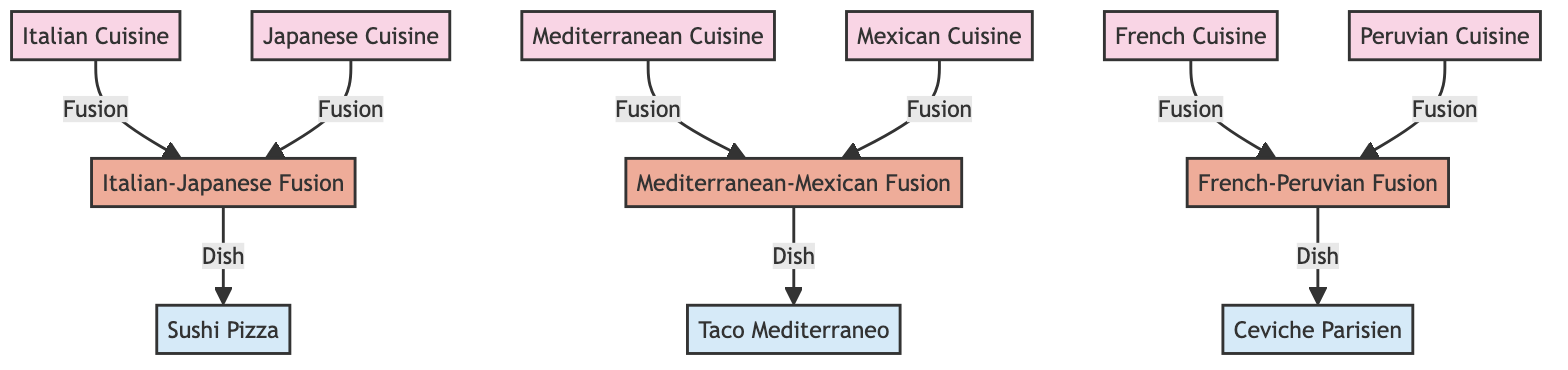What are the different cuisines represented in the diagram? The diagram contains nodes for Italian Cuisine, Japanese Cuisine, Mexican Cuisine, Mediterranean Cuisine, Peruvian Cuisine, and French Cuisine.
Answer: Italian Cuisine, Japanese Cuisine, Mexican Cuisine, Mediterranean Cuisine, Peruvian Cuisine, French Cuisine How many fusion cuisine types are listed? The diagram shows three fusion cuisine types: Italian-Japanese Fusion, Mediterranean-Mexican Fusion, and French-Peruvian Fusion.
Answer: Three What dish is associated with Italian-Japanese Fusion? According to the diagram, the dish associated with Italian-Japanese Fusion is Sushi Pizza.
Answer: Sushi Pizza Which cuisines influence the Mediterranean-Mexican Fusion? The Mediterranean-Mexican Fusion is influenced by Mediterranean Cuisine and Mexican Cuisine, as indicated by the edges connecting them.
Answer: Mediterranean Cuisine, Mexican Cuisine Which dish is associated with the French-Peruvian Fusion? The diagram indicates that the dish associated with the French-Peruvian Fusion is Ceviche Parisien.
Answer: Ceviche Parisien How many dishes are represented in the diagram? There are three dishes represented: Sushi Pizza, Taco Mediterraneo, and Ceviche Parisien. This can be confirmed by counting the nodes labeled as dishes.
Answer: Three Which cuisine is connected to both Japanese and Italian cuisines in the diagram? The Italian-Japanese Fusion node connects both Japanese Cuisine and Italian Cuisine, as indicated by the edges leading to it.
Answer: Italian-Japanese Fusion What is the relationship between Mediterranean Cuisine and Mexican Cuisine? The diagram indicates that there is a fusion relationship between Mediterranean Cuisine and Mexican Cuisine, as shown by the connecting edge labeled "Fusion."
Answer: Fusion 